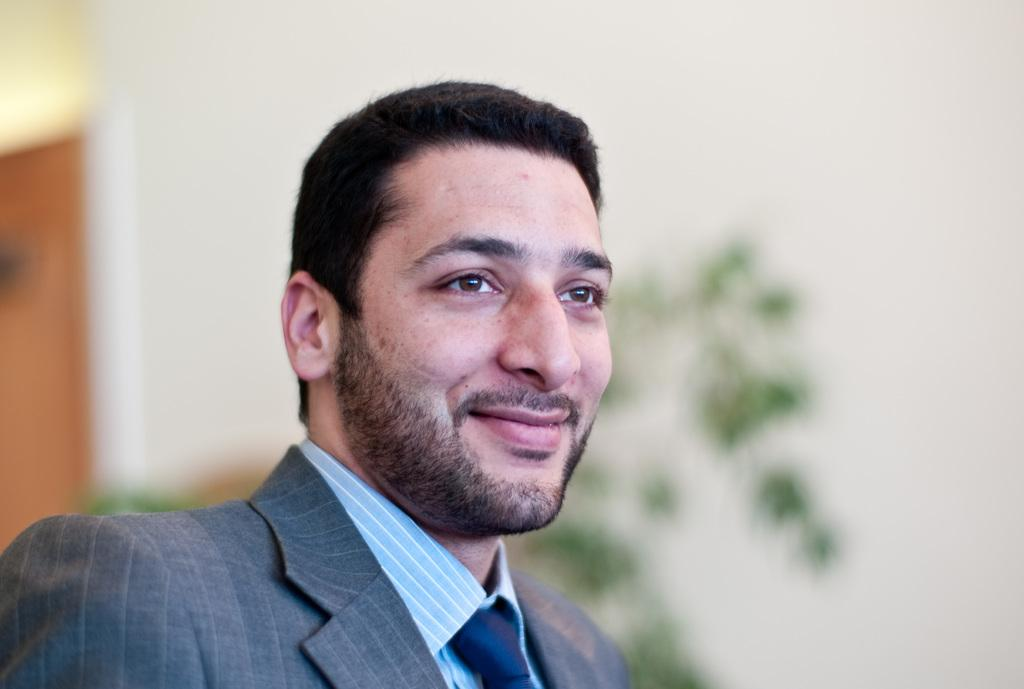Who or what is present in the image? There is a person in the image. What is the person doing or expressing? The person is smiling. Can you describe the background of the image? The background of the image is blurry. What can be seen in the background of the image? There is a wall and a plant in the background of the image. How does the person increase the size of the nail in the image? There is no nail present in the image, so it is not possible to answer that question. 